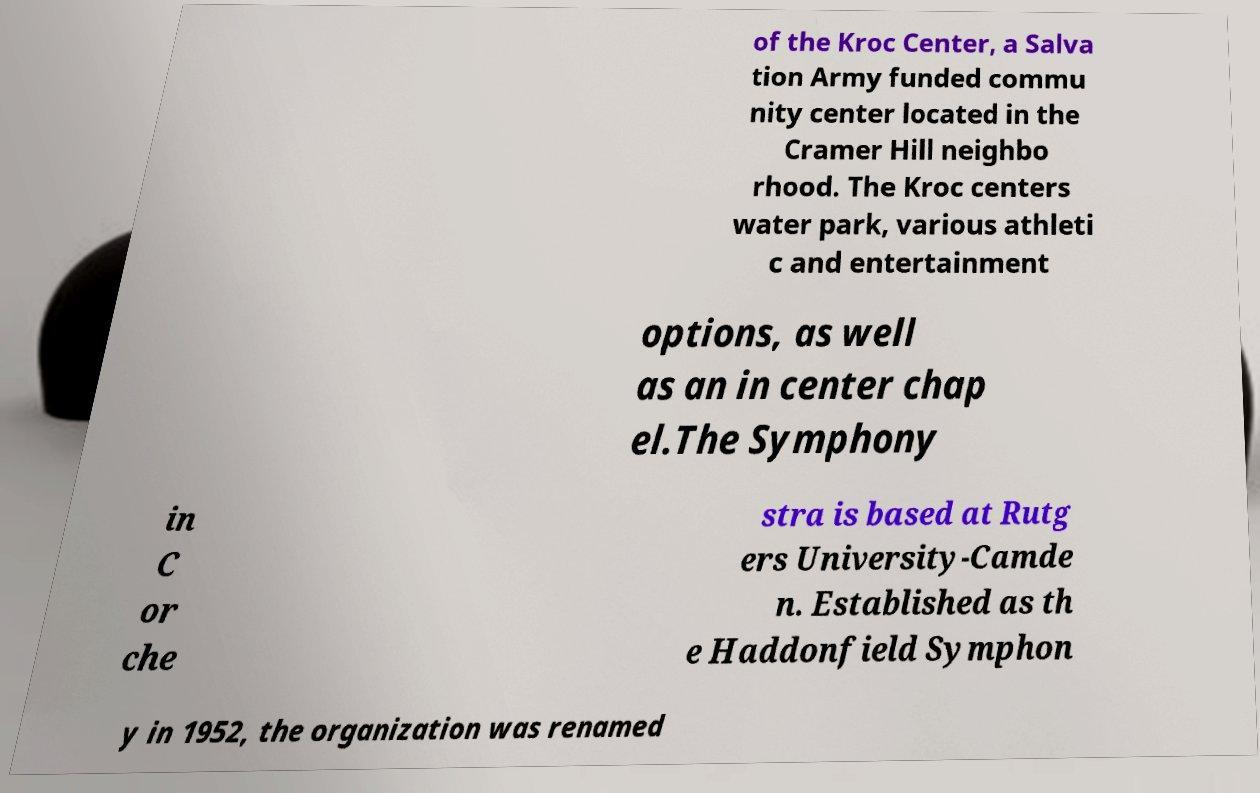Could you extract and type out the text from this image? of the Kroc Center, a Salva tion Army funded commu nity center located in the Cramer Hill neighbo rhood. The Kroc centers water park, various athleti c and entertainment options, as well as an in center chap el.The Symphony in C or che stra is based at Rutg ers University-Camde n. Established as th e Haddonfield Symphon y in 1952, the organization was renamed 